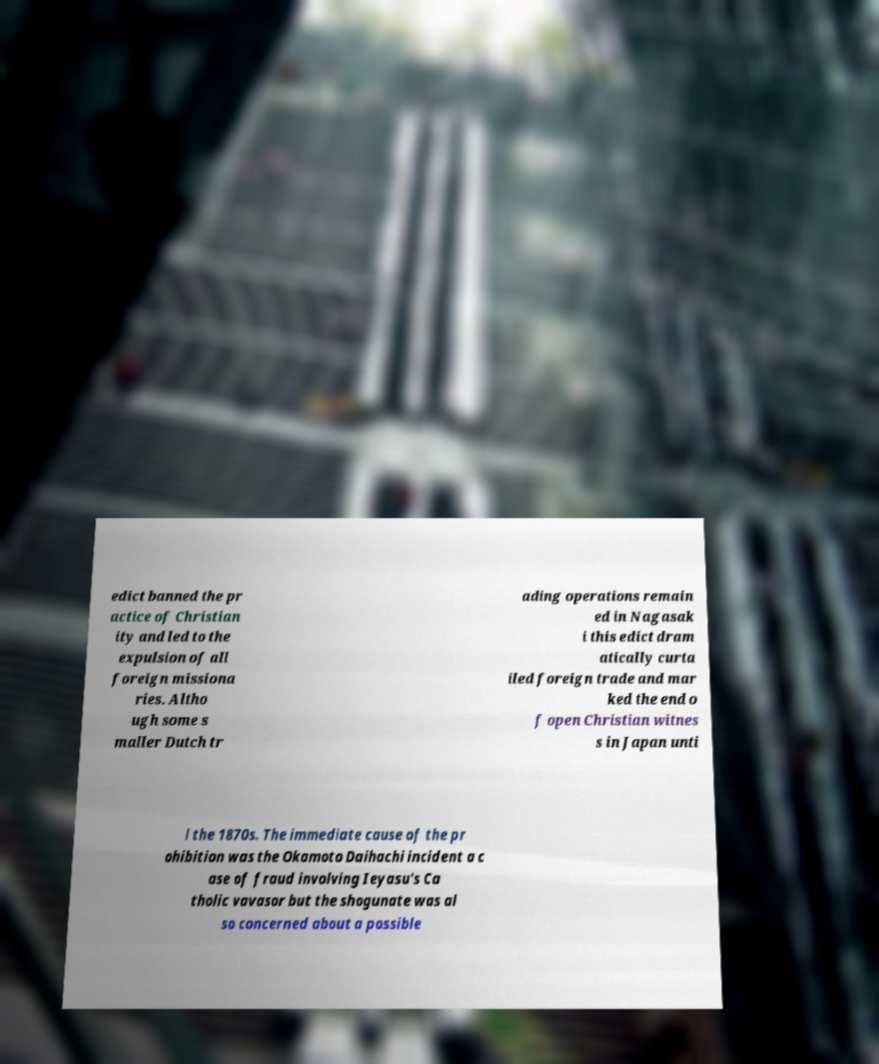There's text embedded in this image that I need extracted. Can you transcribe it verbatim? edict banned the pr actice of Christian ity and led to the expulsion of all foreign missiona ries. Altho ugh some s maller Dutch tr ading operations remain ed in Nagasak i this edict dram atically curta iled foreign trade and mar ked the end o f open Christian witnes s in Japan unti l the 1870s. The immediate cause of the pr ohibition was the Okamoto Daihachi incident a c ase of fraud involving Ieyasu's Ca tholic vavasor but the shogunate was al so concerned about a possible 